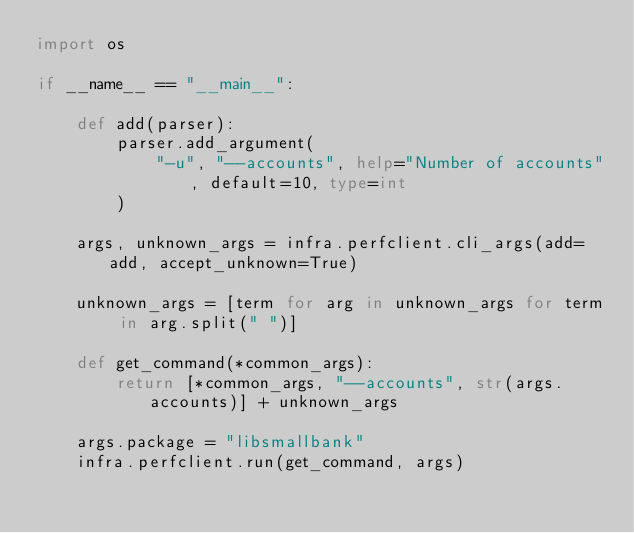<code> <loc_0><loc_0><loc_500><loc_500><_Python_>import os

if __name__ == "__main__":

    def add(parser):
        parser.add_argument(
            "-u", "--accounts", help="Number of accounts", default=10, type=int
        )

    args, unknown_args = infra.perfclient.cli_args(add=add, accept_unknown=True)

    unknown_args = [term for arg in unknown_args for term in arg.split(" ")]

    def get_command(*common_args):
        return [*common_args, "--accounts", str(args.accounts)] + unknown_args

    args.package = "libsmallbank"
    infra.perfclient.run(get_command, args)
</code> 